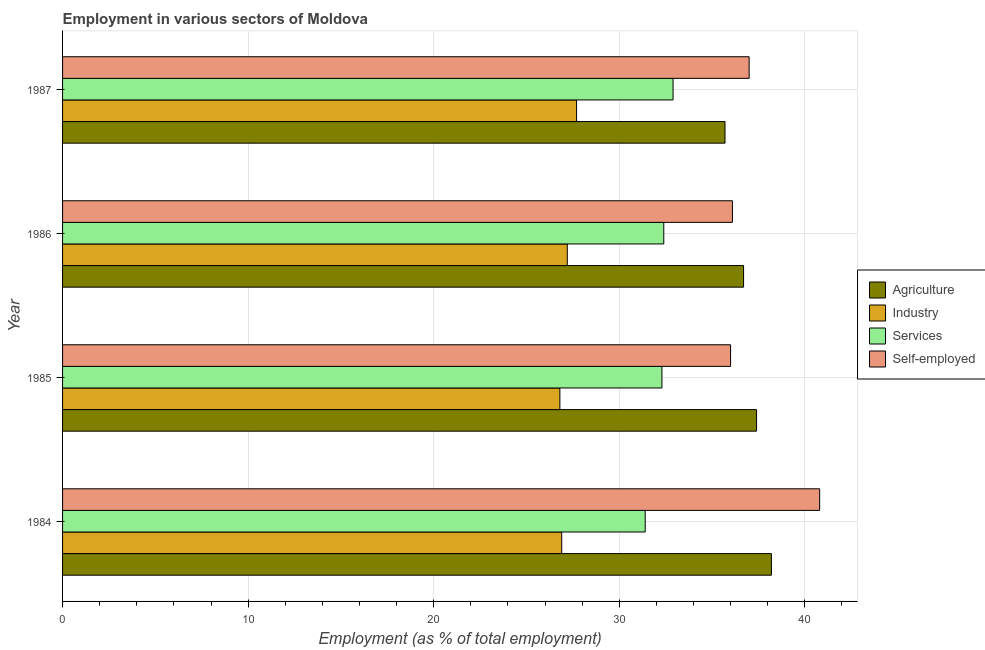How many different coloured bars are there?
Make the answer very short. 4. Are the number of bars per tick equal to the number of legend labels?
Ensure brevity in your answer.  Yes. How many bars are there on the 1st tick from the top?
Offer a very short reply. 4. Across all years, what is the maximum percentage of self employed workers?
Your response must be concise. 40.8. Across all years, what is the minimum percentage of self employed workers?
Your answer should be compact. 36. What is the total percentage of workers in services in the graph?
Your response must be concise. 129. What is the difference between the percentage of workers in services in 1987 and the percentage of workers in industry in 1984?
Provide a succinct answer. 6. What is the average percentage of workers in industry per year?
Provide a short and direct response. 27.15. In how many years, is the percentage of self employed workers greater than 16 %?
Your response must be concise. 4. Is the difference between the percentage of self employed workers in 1985 and 1986 greater than the difference between the percentage of workers in agriculture in 1985 and 1986?
Provide a short and direct response. No. What is the difference between the highest and the lowest percentage of self employed workers?
Offer a terse response. 4.8. In how many years, is the percentage of workers in services greater than the average percentage of workers in services taken over all years?
Make the answer very short. 3. Is it the case that in every year, the sum of the percentage of workers in services and percentage of workers in industry is greater than the sum of percentage of workers in agriculture and percentage of self employed workers?
Offer a terse response. No. What does the 3rd bar from the top in 1985 represents?
Your answer should be very brief. Industry. What does the 4th bar from the bottom in 1987 represents?
Make the answer very short. Self-employed. How many bars are there?
Provide a succinct answer. 16. How many years are there in the graph?
Offer a terse response. 4. Are the values on the major ticks of X-axis written in scientific E-notation?
Offer a very short reply. No. Where does the legend appear in the graph?
Make the answer very short. Center right. How many legend labels are there?
Your answer should be compact. 4. How are the legend labels stacked?
Provide a succinct answer. Vertical. What is the title of the graph?
Ensure brevity in your answer.  Employment in various sectors of Moldova. What is the label or title of the X-axis?
Keep it short and to the point. Employment (as % of total employment). What is the Employment (as % of total employment) in Agriculture in 1984?
Keep it short and to the point. 38.2. What is the Employment (as % of total employment) of Industry in 1984?
Provide a succinct answer. 26.9. What is the Employment (as % of total employment) of Services in 1984?
Make the answer very short. 31.4. What is the Employment (as % of total employment) of Self-employed in 1984?
Your response must be concise. 40.8. What is the Employment (as % of total employment) in Agriculture in 1985?
Your answer should be compact. 37.4. What is the Employment (as % of total employment) in Industry in 1985?
Give a very brief answer. 26.8. What is the Employment (as % of total employment) in Services in 1985?
Keep it short and to the point. 32.3. What is the Employment (as % of total employment) of Agriculture in 1986?
Keep it short and to the point. 36.7. What is the Employment (as % of total employment) in Industry in 1986?
Your response must be concise. 27.2. What is the Employment (as % of total employment) in Services in 1986?
Your answer should be very brief. 32.4. What is the Employment (as % of total employment) of Self-employed in 1986?
Your answer should be compact. 36.1. What is the Employment (as % of total employment) of Agriculture in 1987?
Your answer should be very brief. 35.7. What is the Employment (as % of total employment) of Industry in 1987?
Offer a terse response. 27.7. What is the Employment (as % of total employment) in Services in 1987?
Keep it short and to the point. 32.9. What is the Employment (as % of total employment) in Self-employed in 1987?
Your answer should be compact. 37. Across all years, what is the maximum Employment (as % of total employment) of Agriculture?
Offer a terse response. 38.2. Across all years, what is the maximum Employment (as % of total employment) of Industry?
Ensure brevity in your answer.  27.7. Across all years, what is the maximum Employment (as % of total employment) of Services?
Provide a succinct answer. 32.9. Across all years, what is the maximum Employment (as % of total employment) of Self-employed?
Give a very brief answer. 40.8. Across all years, what is the minimum Employment (as % of total employment) in Agriculture?
Your answer should be compact. 35.7. Across all years, what is the minimum Employment (as % of total employment) of Industry?
Provide a short and direct response. 26.8. Across all years, what is the minimum Employment (as % of total employment) in Services?
Ensure brevity in your answer.  31.4. What is the total Employment (as % of total employment) of Agriculture in the graph?
Offer a terse response. 148. What is the total Employment (as % of total employment) of Industry in the graph?
Provide a short and direct response. 108.6. What is the total Employment (as % of total employment) in Services in the graph?
Ensure brevity in your answer.  129. What is the total Employment (as % of total employment) in Self-employed in the graph?
Ensure brevity in your answer.  149.9. What is the difference between the Employment (as % of total employment) in Services in 1984 and that in 1985?
Provide a succinct answer. -0.9. What is the difference between the Employment (as % of total employment) of Self-employed in 1984 and that in 1985?
Ensure brevity in your answer.  4.8. What is the difference between the Employment (as % of total employment) of Agriculture in 1984 and that in 1986?
Keep it short and to the point. 1.5. What is the difference between the Employment (as % of total employment) in Industry in 1984 and that in 1986?
Make the answer very short. -0.3. What is the difference between the Employment (as % of total employment) of Services in 1984 and that in 1986?
Keep it short and to the point. -1. What is the difference between the Employment (as % of total employment) in Agriculture in 1984 and that in 1987?
Your response must be concise. 2.5. What is the difference between the Employment (as % of total employment) in Agriculture in 1985 and that in 1986?
Make the answer very short. 0.7. What is the difference between the Employment (as % of total employment) of Services in 1985 and that in 1986?
Provide a short and direct response. -0.1. What is the difference between the Employment (as % of total employment) in Self-employed in 1985 and that in 1986?
Make the answer very short. -0.1. What is the difference between the Employment (as % of total employment) of Agriculture in 1985 and that in 1987?
Make the answer very short. 1.7. What is the difference between the Employment (as % of total employment) of Services in 1985 and that in 1987?
Provide a short and direct response. -0.6. What is the difference between the Employment (as % of total employment) in Self-employed in 1985 and that in 1987?
Your response must be concise. -1. What is the difference between the Employment (as % of total employment) in Agriculture in 1984 and the Employment (as % of total employment) in Industry in 1985?
Offer a terse response. 11.4. What is the difference between the Employment (as % of total employment) of Agriculture in 1984 and the Employment (as % of total employment) of Services in 1985?
Make the answer very short. 5.9. What is the difference between the Employment (as % of total employment) of Industry in 1984 and the Employment (as % of total employment) of Services in 1985?
Keep it short and to the point. -5.4. What is the difference between the Employment (as % of total employment) in Industry in 1984 and the Employment (as % of total employment) in Self-employed in 1985?
Provide a short and direct response. -9.1. What is the difference between the Employment (as % of total employment) in Services in 1984 and the Employment (as % of total employment) in Self-employed in 1986?
Ensure brevity in your answer.  -4.7. What is the difference between the Employment (as % of total employment) in Agriculture in 1984 and the Employment (as % of total employment) in Industry in 1987?
Provide a short and direct response. 10.5. What is the difference between the Employment (as % of total employment) in Agriculture in 1984 and the Employment (as % of total employment) in Services in 1987?
Offer a terse response. 5.3. What is the difference between the Employment (as % of total employment) of Services in 1984 and the Employment (as % of total employment) of Self-employed in 1987?
Your response must be concise. -5.6. What is the difference between the Employment (as % of total employment) in Agriculture in 1985 and the Employment (as % of total employment) in Industry in 1986?
Offer a terse response. 10.2. What is the difference between the Employment (as % of total employment) in Industry in 1985 and the Employment (as % of total employment) in Services in 1986?
Give a very brief answer. -5.6. What is the difference between the Employment (as % of total employment) in Industry in 1985 and the Employment (as % of total employment) in Self-employed in 1986?
Offer a terse response. -9.3. What is the difference between the Employment (as % of total employment) of Industry in 1985 and the Employment (as % of total employment) of Self-employed in 1987?
Ensure brevity in your answer.  -10.2. What is the difference between the Employment (as % of total employment) of Services in 1985 and the Employment (as % of total employment) of Self-employed in 1987?
Your answer should be compact. -4.7. What is the difference between the Employment (as % of total employment) in Agriculture in 1986 and the Employment (as % of total employment) in Services in 1987?
Your response must be concise. 3.8. What is the difference between the Employment (as % of total employment) of Industry in 1986 and the Employment (as % of total employment) of Services in 1987?
Your answer should be very brief. -5.7. What is the difference between the Employment (as % of total employment) of Industry in 1986 and the Employment (as % of total employment) of Self-employed in 1987?
Provide a short and direct response. -9.8. What is the difference between the Employment (as % of total employment) in Services in 1986 and the Employment (as % of total employment) in Self-employed in 1987?
Your response must be concise. -4.6. What is the average Employment (as % of total employment) of Agriculture per year?
Offer a very short reply. 37. What is the average Employment (as % of total employment) in Industry per year?
Give a very brief answer. 27.15. What is the average Employment (as % of total employment) of Services per year?
Your answer should be compact. 32.25. What is the average Employment (as % of total employment) in Self-employed per year?
Your answer should be compact. 37.48. In the year 1984, what is the difference between the Employment (as % of total employment) in Industry and Employment (as % of total employment) in Self-employed?
Make the answer very short. -13.9. In the year 1985, what is the difference between the Employment (as % of total employment) in Agriculture and Employment (as % of total employment) in Services?
Provide a succinct answer. 5.1. In the year 1985, what is the difference between the Employment (as % of total employment) of Industry and Employment (as % of total employment) of Self-employed?
Provide a short and direct response. -9.2. In the year 1985, what is the difference between the Employment (as % of total employment) in Services and Employment (as % of total employment) in Self-employed?
Your response must be concise. -3.7. In the year 1986, what is the difference between the Employment (as % of total employment) of Industry and Employment (as % of total employment) of Services?
Give a very brief answer. -5.2. In the year 1986, what is the difference between the Employment (as % of total employment) in Services and Employment (as % of total employment) in Self-employed?
Ensure brevity in your answer.  -3.7. In the year 1987, what is the difference between the Employment (as % of total employment) in Agriculture and Employment (as % of total employment) in Self-employed?
Your answer should be very brief. -1.3. In the year 1987, what is the difference between the Employment (as % of total employment) in Services and Employment (as % of total employment) in Self-employed?
Provide a short and direct response. -4.1. What is the ratio of the Employment (as % of total employment) in Agriculture in 1984 to that in 1985?
Your answer should be very brief. 1.02. What is the ratio of the Employment (as % of total employment) in Industry in 1984 to that in 1985?
Offer a very short reply. 1. What is the ratio of the Employment (as % of total employment) of Services in 1984 to that in 1985?
Ensure brevity in your answer.  0.97. What is the ratio of the Employment (as % of total employment) of Self-employed in 1984 to that in 1985?
Your response must be concise. 1.13. What is the ratio of the Employment (as % of total employment) of Agriculture in 1984 to that in 1986?
Provide a short and direct response. 1.04. What is the ratio of the Employment (as % of total employment) of Services in 1984 to that in 1986?
Your answer should be very brief. 0.97. What is the ratio of the Employment (as % of total employment) of Self-employed in 1984 to that in 1986?
Offer a very short reply. 1.13. What is the ratio of the Employment (as % of total employment) of Agriculture in 1984 to that in 1987?
Offer a very short reply. 1.07. What is the ratio of the Employment (as % of total employment) of Industry in 1984 to that in 1987?
Provide a short and direct response. 0.97. What is the ratio of the Employment (as % of total employment) in Services in 1984 to that in 1987?
Offer a very short reply. 0.95. What is the ratio of the Employment (as % of total employment) of Self-employed in 1984 to that in 1987?
Offer a very short reply. 1.1. What is the ratio of the Employment (as % of total employment) in Agriculture in 1985 to that in 1986?
Provide a short and direct response. 1.02. What is the ratio of the Employment (as % of total employment) in Industry in 1985 to that in 1986?
Your response must be concise. 0.99. What is the ratio of the Employment (as % of total employment) of Services in 1985 to that in 1986?
Give a very brief answer. 1. What is the ratio of the Employment (as % of total employment) of Self-employed in 1985 to that in 1986?
Your response must be concise. 1. What is the ratio of the Employment (as % of total employment) in Agriculture in 1985 to that in 1987?
Ensure brevity in your answer.  1.05. What is the ratio of the Employment (as % of total employment) in Industry in 1985 to that in 1987?
Offer a terse response. 0.97. What is the ratio of the Employment (as % of total employment) in Services in 1985 to that in 1987?
Provide a succinct answer. 0.98. What is the ratio of the Employment (as % of total employment) in Self-employed in 1985 to that in 1987?
Keep it short and to the point. 0.97. What is the ratio of the Employment (as % of total employment) in Agriculture in 1986 to that in 1987?
Make the answer very short. 1.03. What is the ratio of the Employment (as % of total employment) of Industry in 1986 to that in 1987?
Ensure brevity in your answer.  0.98. What is the ratio of the Employment (as % of total employment) in Services in 1986 to that in 1987?
Ensure brevity in your answer.  0.98. What is the ratio of the Employment (as % of total employment) of Self-employed in 1986 to that in 1987?
Keep it short and to the point. 0.98. What is the difference between the highest and the second highest Employment (as % of total employment) of Industry?
Keep it short and to the point. 0.5. What is the difference between the highest and the second highest Employment (as % of total employment) of Self-employed?
Ensure brevity in your answer.  3.8. What is the difference between the highest and the lowest Employment (as % of total employment) in Industry?
Your answer should be very brief. 0.9. What is the difference between the highest and the lowest Employment (as % of total employment) in Services?
Your answer should be compact. 1.5. 